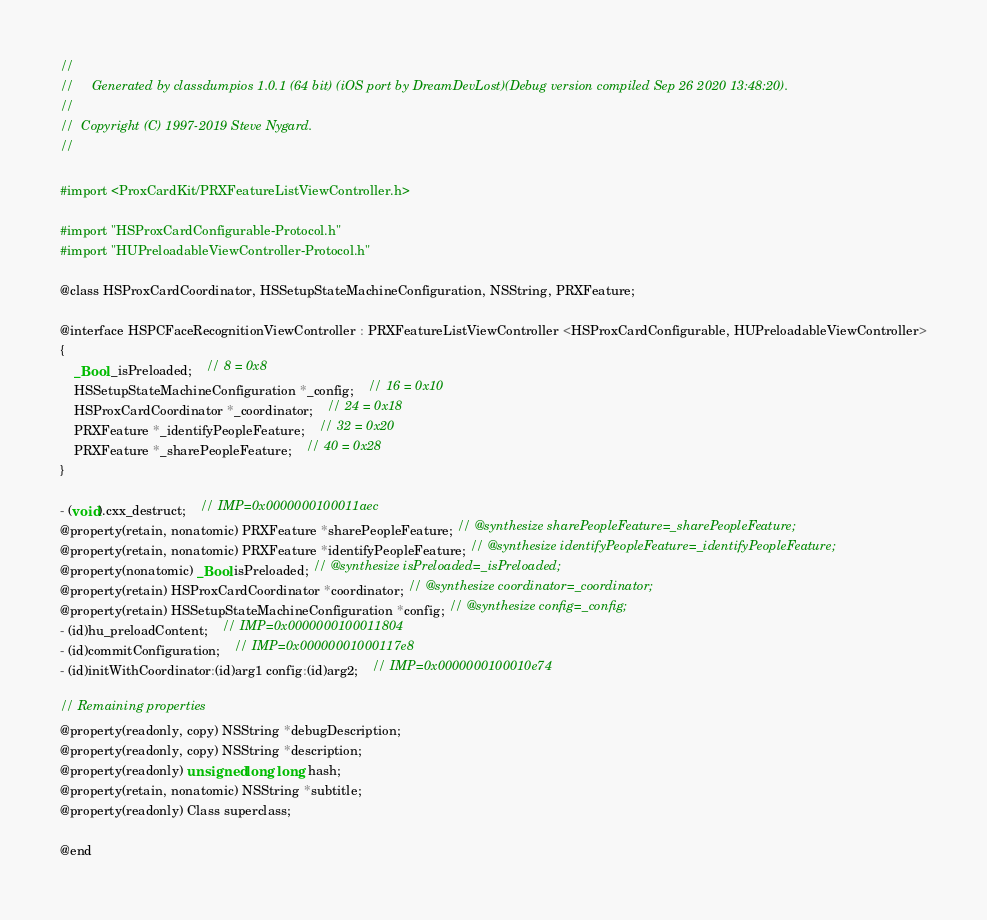Convert code to text. <code><loc_0><loc_0><loc_500><loc_500><_C_>//
//     Generated by classdumpios 1.0.1 (64 bit) (iOS port by DreamDevLost)(Debug version compiled Sep 26 2020 13:48:20).
//
//  Copyright (C) 1997-2019 Steve Nygard.
//

#import <ProxCardKit/PRXFeatureListViewController.h>

#import "HSProxCardConfigurable-Protocol.h"
#import "HUPreloadableViewController-Protocol.h"

@class HSProxCardCoordinator, HSSetupStateMachineConfiguration, NSString, PRXFeature;

@interface HSPCFaceRecognitionViewController : PRXFeatureListViewController <HSProxCardConfigurable, HUPreloadableViewController>
{
    _Bool _isPreloaded;	// 8 = 0x8
    HSSetupStateMachineConfiguration *_config;	// 16 = 0x10
    HSProxCardCoordinator *_coordinator;	// 24 = 0x18
    PRXFeature *_identifyPeopleFeature;	// 32 = 0x20
    PRXFeature *_sharePeopleFeature;	// 40 = 0x28
}

- (void).cxx_destruct;	// IMP=0x0000000100011aec
@property(retain, nonatomic) PRXFeature *sharePeopleFeature; // @synthesize sharePeopleFeature=_sharePeopleFeature;
@property(retain, nonatomic) PRXFeature *identifyPeopleFeature; // @synthesize identifyPeopleFeature=_identifyPeopleFeature;
@property(nonatomic) _Bool isPreloaded; // @synthesize isPreloaded=_isPreloaded;
@property(retain) HSProxCardCoordinator *coordinator; // @synthesize coordinator=_coordinator;
@property(retain) HSSetupStateMachineConfiguration *config; // @synthesize config=_config;
- (id)hu_preloadContent;	// IMP=0x0000000100011804
- (id)commitConfiguration;	// IMP=0x00000001000117e8
- (id)initWithCoordinator:(id)arg1 config:(id)arg2;	// IMP=0x0000000100010e74

// Remaining properties
@property(readonly, copy) NSString *debugDescription;
@property(readonly, copy) NSString *description;
@property(readonly) unsigned long long hash;
@property(retain, nonatomic) NSString *subtitle;
@property(readonly) Class superclass;

@end

</code> 